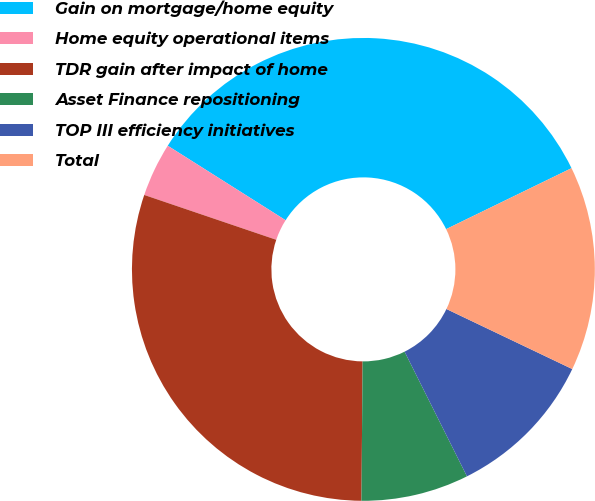Convert chart. <chart><loc_0><loc_0><loc_500><loc_500><pie_chart><fcel>Gain on mortgage/home equity<fcel>Home equity operational items<fcel>TDR gain after impact of home<fcel>Asset Finance repositioning<fcel>TOP III efficiency initiatives<fcel>Total<nl><fcel>33.83%<fcel>3.76%<fcel>30.08%<fcel>7.52%<fcel>10.53%<fcel>14.29%<nl></chart> 